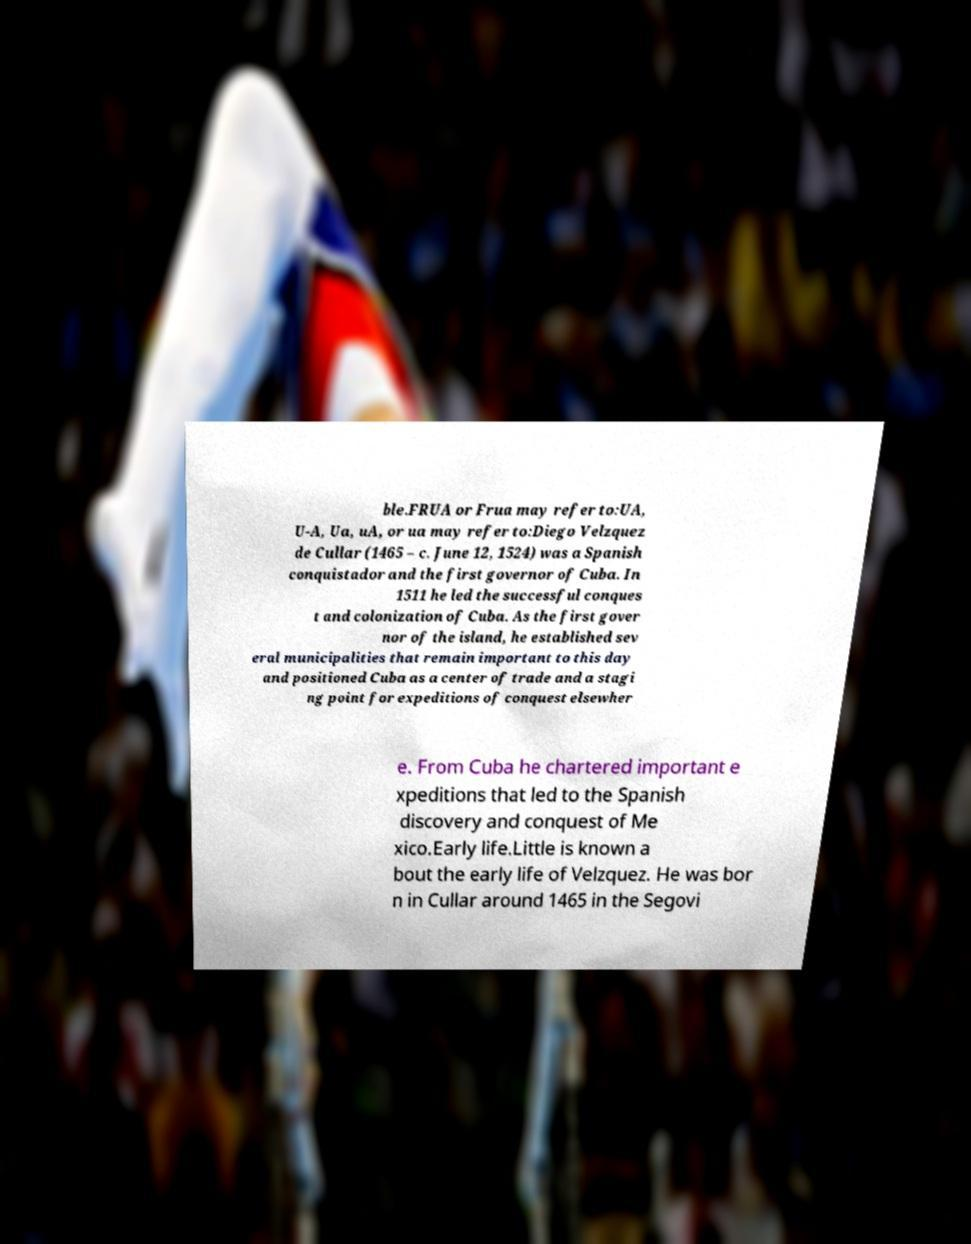Could you assist in decoding the text presented in this image and type it out clearly? ble.FRUA or Frua may refer to:UA, U-A, Ua, uA, or ua may refer to:Diego Velzquez de Cullar (1465 – c. June 12, 1524) was a Spanish conquistador and the first governor of Cuba. In 1511 he led the successful conques t and colonization of Cuba. As the first gover nor of the island, he established sev eral municipalities that remain important to this day and positioned Cuba as a center of trade and a stagi ng point for expeditions of conquest elsewher e. From Cuba he chartered important e xpeditions that led to the Spanish discovery and conquest of Me xico.Early life.Little is known a bout the early life of Velzquez. He was bor n in Cullar around 1465 in the Segovi 